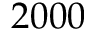<formula> <loc_0><loc_0><loc_500><loc_500>2 0 0 0</formula> 